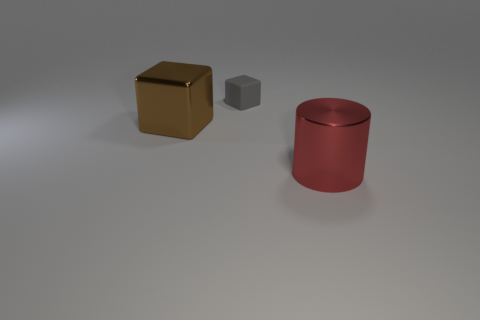Add 2 small gray matte objects. How many objects exist? 5 Subtract all cubes. How many objects are left? 1 Add 1 big brown shiny blocks. How many big brown shiny blocks exist? 2 Subtract 1 red cylinders. How many objects are left? 2 Subtract all cyan metallic blocks. Subtract all brown objects. How many objects are left? 2 Add 2 red cylinders. How many red cylinders are left? 3 